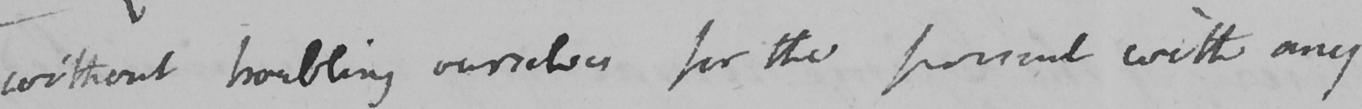Please transcribe the handwritten text in this image. without humbling ourselves for the present with any 